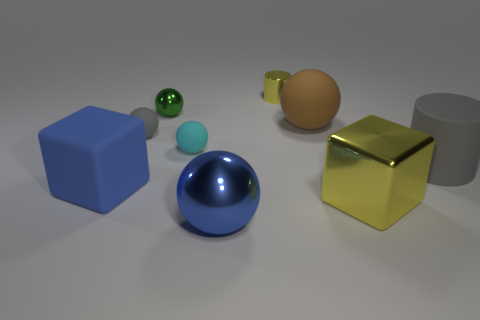Are there fewer rubber things that are in front of the big gray cylinder than objects? Upon examining the image, we can determine that there are a few rubber-like objects present. However, 'rubber things' may refer to objects such as the small green and light blue spheres which appear to have a rubber texture. If we consider those as the 'rubber things,' then there are fewer rubber objects in front of the gray cylinder compared to the total number of objects in the scene. 